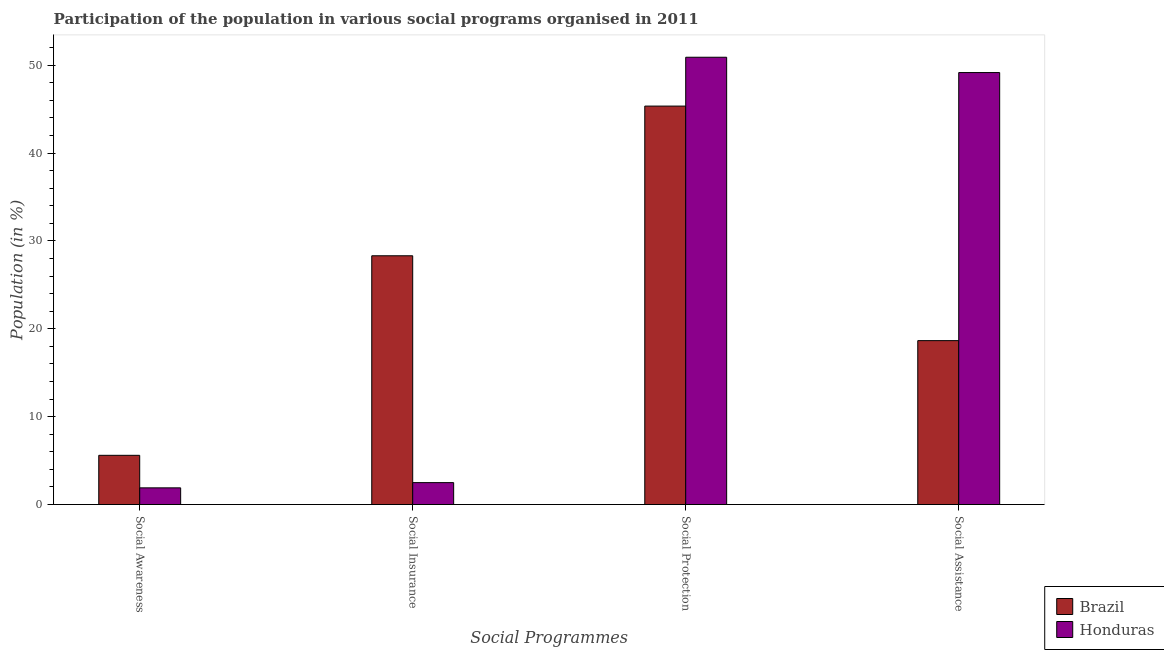How many different coloured bars are there?
Provide a succinct answer. 2. Are the number of bars per tick equal to the number of legend labels?
Offer a very short reply. Yes. Are the number of bars on each tick of the X-axis equal?
Offer a very short reply. Yes. How many bars are there on the 4th tick from the right?
Your answer should be very brief. 2. What is the label of the 3rd group of bars from the left?
Offer a very short reply. Social Protection. What is the participation of population in social assistance programs in Brazil?
Make the answer very short. 18.65. Across all countries, what is the maximum participation of population in social assistance programs?
Give a very brief answer. 49.16. Across all countries, what is the minimum participation of population in social protection programs?
Offer a terse response. 45.34. In which country was the participation of population in social awareness programs maximum?
Your answer should be very brief. Brazil. What is the total participation of population in social awareness programs in the graph?
Provide a succinct answer. 7.5. What is the difference between the participation of population in social protection programs in Brazil and that in Honduras?
Your response must be concise. -5.56. What is the difference between the participation of population in social protection programs in Honduras and the participation of population in social insurance programs in Brazil?
Keep it short and to the point. 22.59. What is the average participation of population in social assistance programs per country?
Your answer should be very brief. 33.91. What is the difference between the participation of population in social insurance programs and participation of population in social protection programs in Honduras?
Provide a short and direct response. -48.41. In how many countries, is the participation of population in social assistance programs greater than 26 %?
Make the answer very short. 1. What is the ratio of the participation of population in social insurance programs in Honduras to that in Brazil?
Ensure brevity in your answer.  0.09. Is the difference between the participation of population in social insurance programs in Honduras and Brazil greater than the difference between the participation of population in social protection programs in Honduras and Brazil?
Your response must be concise. No. What is the difference between the highest and the second highest participation of population in social assistance programs?
Offer a terse response. 30.51. What is the difference between the highest and the lowest participation of population in social awareness programs?
Ensure brevity in your answer.  3.7. In how many countries, is the participation of population in social protection programs greater than the average participation of population in social protection programs taken over all countries?
Ensure brevity in your answer.  1. What does the 2nd bar from the left in Social Insurance represents?
Make the answer very short. Honduras. What does the 1st bar from the right in Social Assistance represents?
Provide a succinct answer. Honduras. Is it the case that in every country, the sum of the participation of population in social awareness programs and participation of population in social insurance programs is greater than the participation of population in social protection programs?
Your answer should be very brief. No. Are all the bars in the graph horizontal?
Ensure brevity in your answer.  No. How many countries are there in the graph?
Provide a succinct answer. 2. What is the difference between two consecutive major ticks on the Y-axis?
Give a very brief answer. 10. Does the graph contain grids?
Offer a very short reply. No. How many legend labels are there?
Provide a succinct answer. 2. What is the title of the graph?
Ensure brevity in your answer.  Participation of the population in various social programs organised in 2011. What is the label or title of the X-axis?
Offer a very short reply. Social Programmes. What is the label or title of the Y-axis?
Your answer should be very brief. Population (in %). What is the Population (in %) of Brazil in Social Awareness?
Make the answer very short. 5.6. What is the Population (in %) in Honduras in Social Awareness?
Provide a short and direct response. 1.9. What is the Population (in %) of Brazil in Social Insurance?
Provide a short and direct response. 28.31. What is the Population (in %) in Honduras in Social Insurance?
Offer a very short reply. 2.49. What is the Population (in %) in Brazil in Social Protection?
Ensure brevity in your answer.  45.34. What is the Population (in %) in Honduras in Social Protection?
Your answer should be very brief. 50.9. What is the Population (in %) of Brazil in Social Assistance?
Ensure brevity in your answer.  18.65. What is the Population (in %) of Honduras in Social Assistance?
Make the answer very short. 49.16. Across all Social Programmes, what is the maximum Population (in %) of Brazil?
Your answer should be compact. 45.34. Across all Social Programmes, what is the maximum Population (in %) of Honduras?
Keep it short and to the point. 50.9. Across all Social Programmes, what is the minimum Population (in %) of Brazil?
Your answer should be very brief. 5.6. Across all Social Programmes, what is the minimum Population (in %) in Honduras?
Provide a short and direct response. 1.9. What is the total Population (in %) in Brazil in the graph?
Provide a short and direct response. 97.91. What is the total Population (in %) in Honduras in the graph?
Your response must be concise. 104.46. What is the difference between the Population (in %) of Brazil in Social Awareness and that in Social Insurance?
Your response must be concise. -22.71. What is the difference between the Population (in %) in Honduras in Social Awareness and that in Social Insurance?
Your response must be concise. -0.59. What is the difference between the Population (in %) of Brazil in Social Awareness and that in Social Protection?
Offer a very short reply. -39.74. What is the difference between the Population (in %) in Honduras in Social Awareness and that in Social Protection?
Offer a very short reply. -49. What is the difference between the Population (in %) of Brazil in Social Awareness and that in Social Assistance?
Make the answer very short. -13.05. What is the difference between the Population (in %) in Honduras in Social Awareness and that in Social Assistance?
Provide a short and direct response. -47.26. What is the difference between the Population (in %) of Brazil in Social Insurance and that in Social Protection?
Your answer should be compact. -17.03. What is the difference between the Population (in %) of Honduras in Social Insurance and that in Social Protection?
Your answer should be very brief. -48.41. What is the difference between the Population (in %) of Brazil in Social Insurance and that in Social Assistance?
Your answer should be compact. 9.66. What is the difference between the Population (in %) of Honduras in Social Insurance and that in Social Assistance?
Give a very brief answer. -46.67. What is the difference between the Population (in %) in Brazil in Social Protection and that in Social Assistance?
Your answer should be very brief. 26.69. What is the difference between the Population (in %) in Honduras in Social Protection and that in Social Assistance?
Make the answer very short. 1.74. What is the difference between the Population (in %) in Brazil in Social Awareness and the Population (in %) in Honduras in Social Insurance?
Your response must be concise. 3.11. What is the difference between the Population (in %) of Brazil in Social Awareness and the Population (in %) of Honduras in Social Protection?
Offer a terse response. -45.3. What is the difference between the Population (in %) of Brazil in Social Awareness and the Population (in %) of Honduras in Social Assistance?
Give a very brief answer. -43.56. What is the difference between the Population (in %) of Brazil in Social Insurance and the Population (in %) of Honduras in Social Protection?
Offer a terse response. -22.59. What is the difference between the Population (in %) in Brazil in Social Insurance and the Population (in %) in Honduras in Social Assistance?
Your response must be concise. -20.85. What is the difference between the Population (in %) in Brazil in Social Protection and the Population (in %) in Honduras in Social Assistance?
Your answer should be very brief. -3.82. What is the average Population (in %) of Brazil per Social Programmes?
Give a very brief answer. 24.48. What is the average Population (in %) of Honduras per Social Programmes?
Offer a very short reply. 26.11. What is the difference between the Population (in %) of Brazil and Population (in %) of Honduras in Social Awareness?
Your answer should be very brief. 3.7. What is the difference between the Population (in %) of Brazil and Population (in %) of Honduras in Social Insurance?
Keep it short and to the point. 25.82. What is the difference between the Population (in %) in Brazil and Population (in %) in Honduras in Social Protection?
Offer a very short reply. -5.56. What is the difference between the Population (in %) of Brazil and Population (in %) of Honduras in Social Assistance?
Offer a terse response. -30.51. What is the ratio of the Population (in %) of Brazil in Social Awareness to that in Social Insurance?
Keep it short and to the point. 0.2. What is the ratio of the Population (in %) in Honduras in Social Awareness to that in Social Insurance?
Offer a terse response. 0.76. What is the ratio of the Population (in %) in Brazil in Social Awareness to that in Social Protection?
Ensure brevity in your answer.  0.12. What is the ratio of the Population (in %) in Honduras in Social Awareness to that in Social Protection?
Your answer should be very brief. 0.04. What is the ratio of the Population (in %) of Brazil in Social Awareness to that in Social Assistance?
Make the answer very short. 0.3. What is the ratio of the Population (in %) of Honduras in Social Awareness to that in Social Assistance?
Keep it short and to the point. 0.04. What is the ratio of the Population (in %) in Brazil in Social Insurance to that in Social Protection?
Your answer should be compact. 0.62. What is the ratio of the Population (in %) of Honduras in Social Insurance to that in Social Protection?
Make the answer very short. 0.05. What is the ratio of the Population (in %) of Brazil in Social Insurance to that in Social Assistance?
Your response must be concise. 1.52. What is the ratio of the Population (in %) of Honduras in Social Insurance to that in Social Assistance?
Provide a short and direct response. 0.05. What is the ratio of the Population (in %) in Brazil in Social Protection to that in Social Assistance?
Your answer should be compact. 2.43. What is the ratio of the Population (in %) of Honduras in Social Protection to that in Social Assistance?
Offer a very short reply. 1.04. What is the difference between the highest and the second highest Population (in %) of Brazil?
Provide a short and direct response. 17.03. What is the difference between the highest and the second highest Population (in %) in Honduras?
Keep it short and to the point. 1.74. What is the difference between the highest and the lowest Population (in %) in Brazil?
Offer a very short reply. 39.74. What is the difference between the highest and the lowest Population (in %) in Honduras?
Ensure brevity in your answer.  49. 